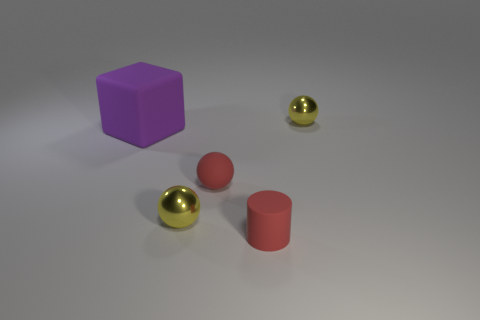Can you infer the time of day or type of lighting used in this image? Considering the evenness and soft quality of the shadows, it is likely the image is set indoors under artificial lighting, rather than being indicative of a natural outdoor setting and time of day. Considering that assessment, what might be the purpose of this arrangement? The purpose isn't clear from the image alone, but this arrangement could be for an educational purpose, like a tutorial in photography or lighting, a display to showcase 3D modeling, or simply an artistic composition meant to highlight shapes and reflections. 